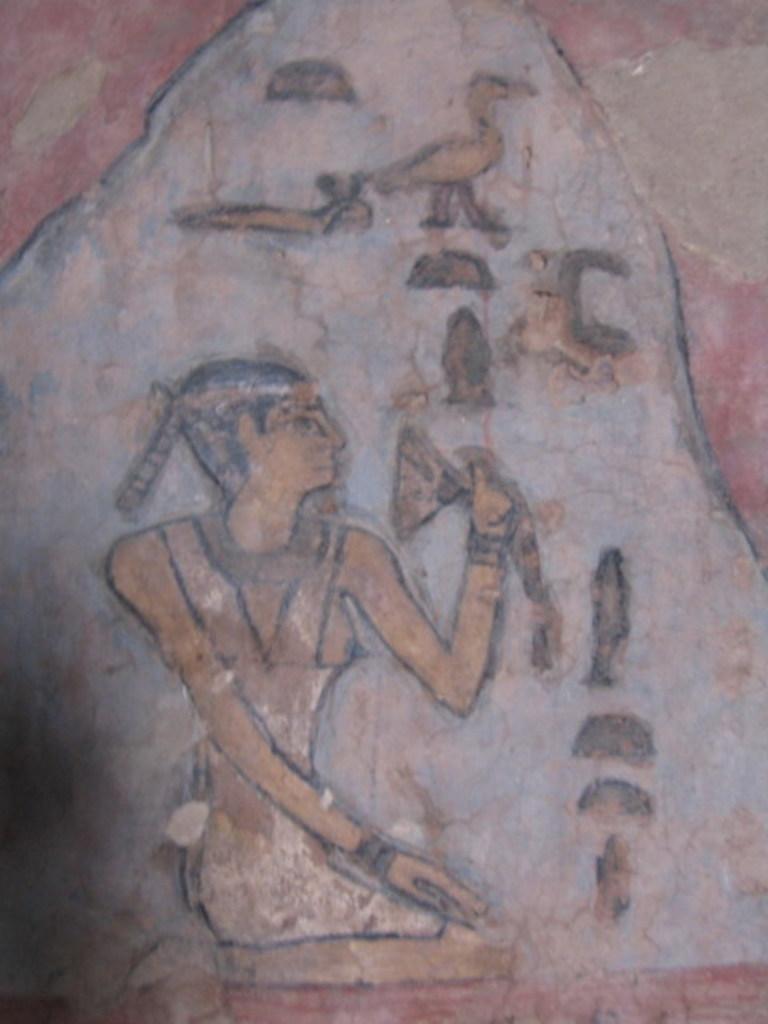In one or two sentences, can you explain what this image depicts? In the center of this picture there is an object on which we can see the drawing of a person, drawing of a bird and the drawings of some other objects. 